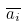Convert formula to latex. <formula><loc_0><loc_0><loc_500><loc_500>\overline { a _ { i } }</formula> 